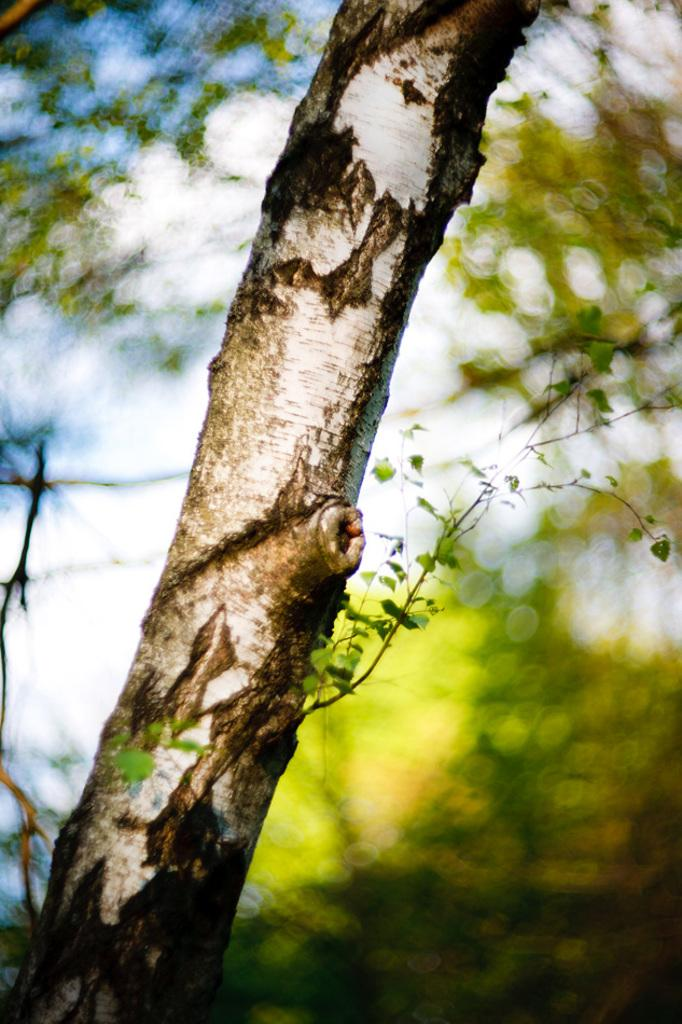What is the main subject of the image? The main subject of the image is a tree branch with plants. Can you describe the plants on the tree branch? Unfortunately, the image does not provide enough detail to describe the plants on the tree branch. What can be seen in the background of the image? There are trees visible in the background of the image, although they are not clearly visible. What type of sign is displayed on the tree branch in the image? There is no sign present on the tree branch in the image. What type of competition is taking place in the image? There is no competition present in the image. What type of punishment is being administered in the image? There is no punishment present in the image. 